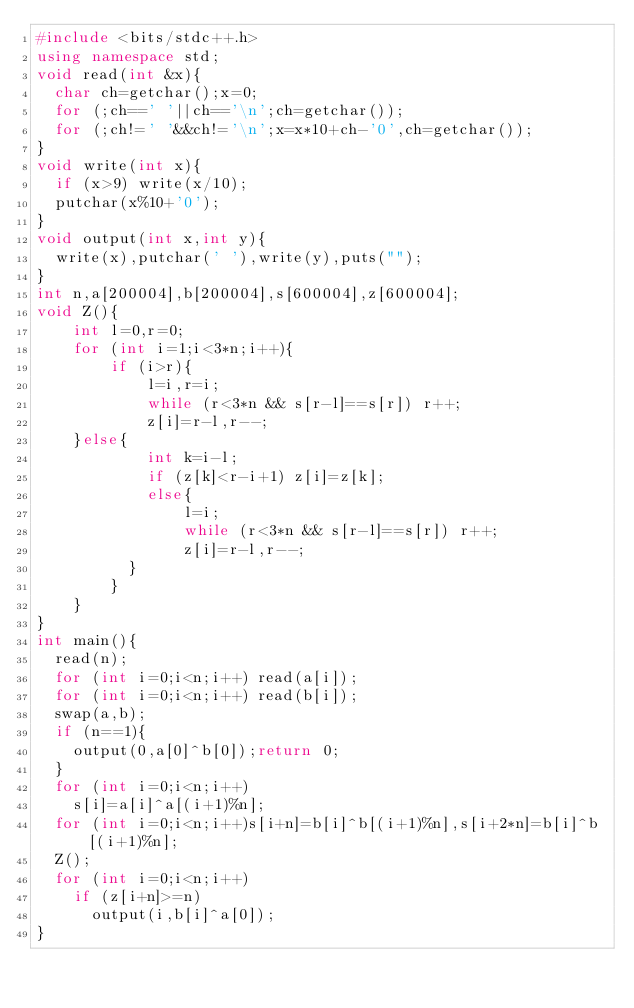<code> <loc_0><loc_0><loc_500><loc_500><_C++_>#include <bits/stdc++.h>
using namespace std;
void read(int &x){
	char ch=getchar();x=0;
	for (;ch==' '||ch=='\n';ch=getchar());
	for (;ch!=' '&&ch!='\n';x=x*10+ch-'0',ch=getchar()); 
}
void write(int x){
	if (x>9) write(x/10);
	putchar(x%10+'0'); 
}
void output(int x,int y){
	write(x),putchar(' '),write(y),puts("");
}
int n,a[200004],b[200004],s[600004],z[600004];
void Z(){
    int l=0,r=0;
    for (int i=1;i<3*n;i++){
        if (i>r){
            l=i,r=i;
            while (r<3*n && s[r-l]==s[r]) r++;
            z[i]=r-l,r--;
		}else{
            int k=i-l;
            if (z[k]<r-i+1) z[i]=z[k];
            else{
                l=i;
                while (r<3*n && s[r-l]==s[r]) r++;
                z[i]=r-l,r--;
        	}
        }
    } 
}
int main(){
	read(n);
	for (int i=0;i<n;i++) read(a[i]);
	for (int i=0;i<n;i++) read(b[i]);
	swap(a,b);
	if (n==1){
		output(0,a[0]^b[0]);return 0;
	}
	for (int i=0;i<n;i++)
		s[i]=a[i]^a[(i+1)%n];
	for (int i=0;i<n;i++)s[i+n]=b[i]^b[(i+1)%n],s[i+2*n]=b[i]^b[(i+1)%n];
	Z();
	for (int i=0;i<n;i++)
		if (z[i+n]>=n)
			output(i,b[i]^a[0]);
}</code> 